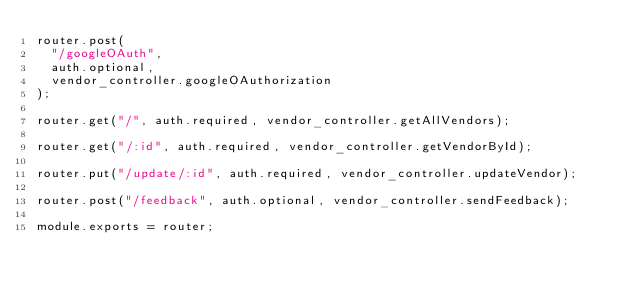<code> <loc_0><loc_0><loc_500><loc_500><_JavaScript_>router.post(
  "/googleOAuth",
  auth.optional,
  vendor_controller.googleOAuthorization
);

router.get("/", auth.required, vendor_controller.getAllVendors);

router.get("/:id", auth.required, vendor_controller.getVendorById);

router.put("/update/:id", auth.required, vendor_controller.updateVendor);

router.post("/feedback", auth.optional, vendor_controller.sendFeedback);

module.exports = router;
</code> 